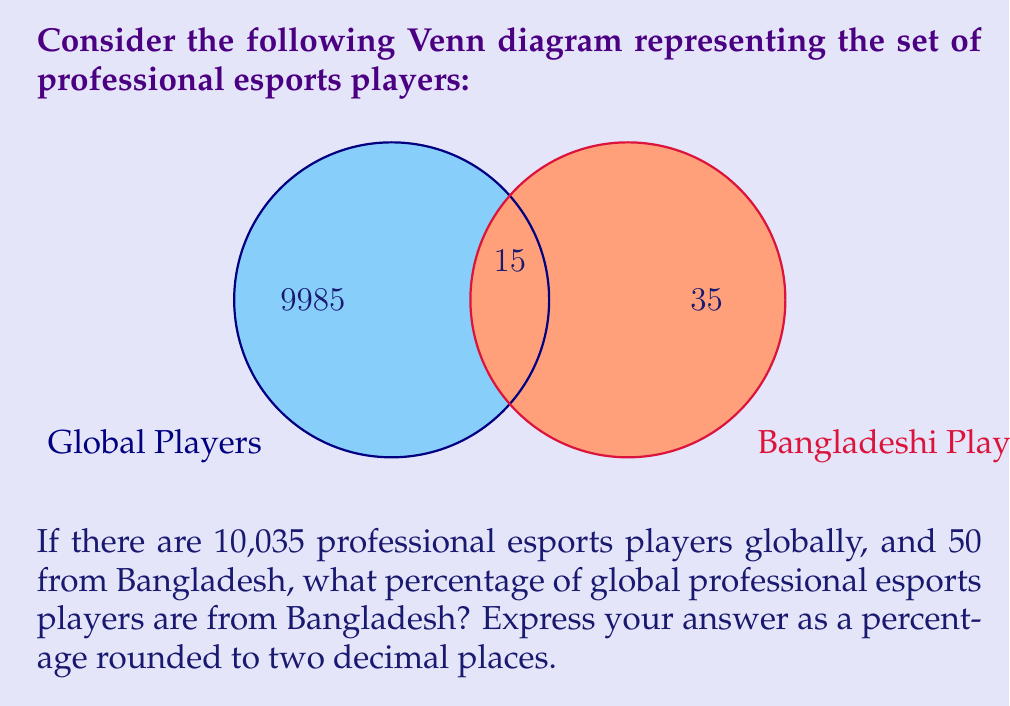Give your solution to this math problem. Let's approach this step-by-step:

1) First, let's identify the sets:
   - Let $G$ be the set of all global professional esports players
   - Let $B$ be the set of professional esports players from Bangladesh

2) From the Venn diagram, we can see that:
   - $|G \setminus B| = 9985$ (players not from Bangladesh)
   - $|G \cap B| = 15$ (players from Bangladesh who are also considered global players)
   - $|B \setminus G| = 35$ (players from Bangladesh not considered global players)

3) To find the total number of players from Bangladesh:
   $|B| = |G \cap B| + |B \setminus G| = 15 + 35 = 50$

4) To find the percentage, we use the formula:
   Percentage = $\frac{\text{Number of Bangladeshi players}}{\text{Total number of global players}} \times 100\%$

5) Plugging in the numbers:
   Percentage = $\frac{50}{10035} \times 100\% = 0.4982561035...\%$

6) Rounding to two decimal places:
   $0.50\%$
Answer: $0.50\%$ 